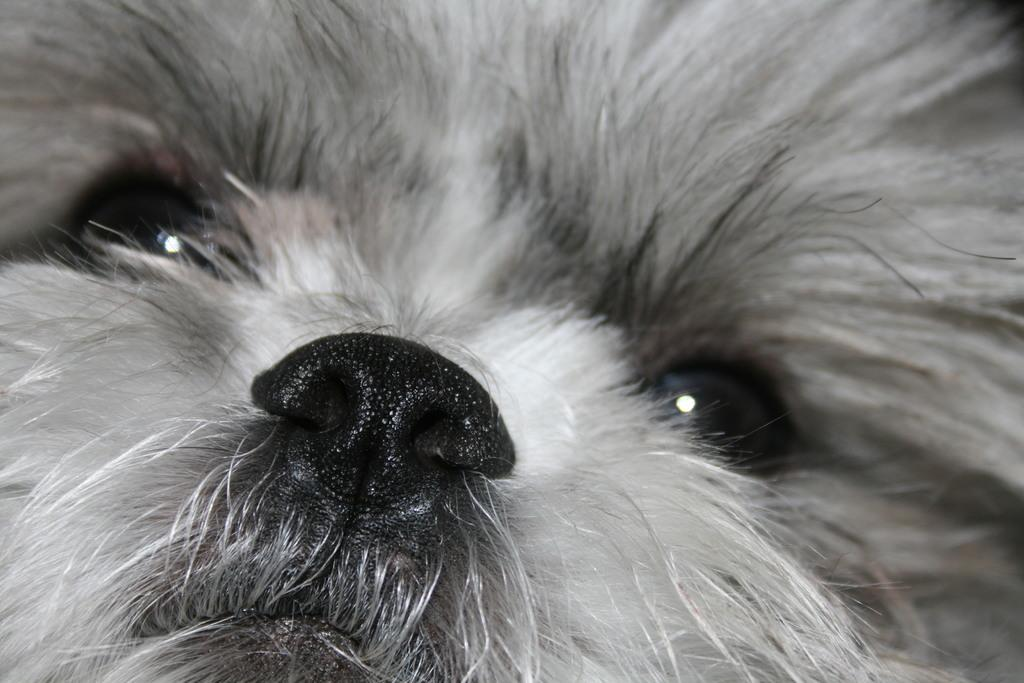What type of animal is present in the image? There is a dog in the image. Can you describe the color of the dog? The dog is black and white in color. Can the dog be seen looking out of a tent in the image? There is no tent present in the image, and the dog is not shown looking out of anything. 